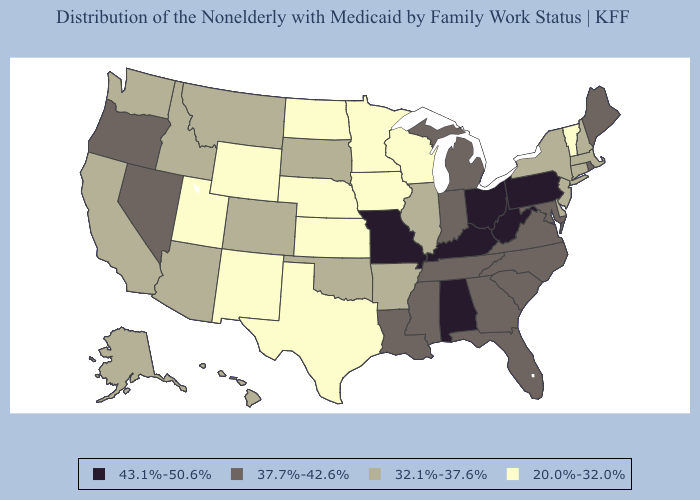Among the states that border Washington , does Oregon have the lowest value?
Give a very brief answer. No. Among the states that border Michigan , does Ohio have the highest value?
Answer briefly. Yes. Among the states that border Iowa , does South Dakota have the highest value?
Short answer required. No. Does Alabama have the highest value in the USA?
Give a very brief answer. Yes. What is the value of Rhode Island?
Concise answer only. 37.7%-42.6%. Which states have the lowest value in the USA?
Write a very short answer. Iowa, Kansas, Minnesota, Nebraska, New Mexico, North Dakota, Texas, Utah, Vermont, Wisconsin, Wyoming. Which states have the highest value in the USA?
Concise answer only. Alabama, Kentucky, Missouri, Ohio, Pennsylvania, West Virginia. What is the value of Oklahoma?
Short answer required. 32.1%-37.6%. Among the states that border Indiana , which have the lowest value?
Concise answer only. Illinois. Name the states that have a value in the range 43.1%-50.6%?
Short answer required. Alabama, Kentucky, Missouri, Ohio, Pennsylvania, West Virginia. What is the value of Kentucky?
Answer briefly. 43.1%-50.6%. Among the states that border New Mexico , does Texas have the lowest value?
Short answer required. Yes. What is the value of Massachusetts?
Write a very short answer. 32.1%-37.6%. Name the states that have a value in the range 43.1%-50.6%?
Write a very short answer. Alabama, Kentucky, Missouri, Ohio, Pennsylvania, West Virginia. 